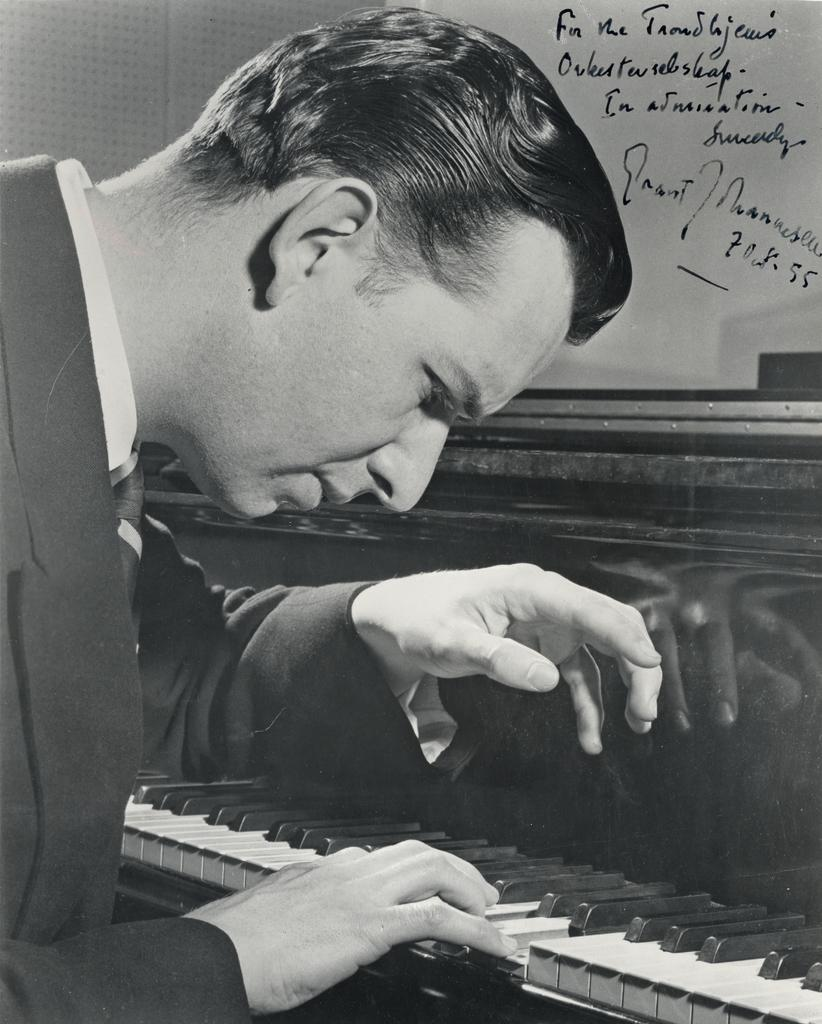What is the color scheme of the image? The image is black and white. What activity is the man in the image engaged in? The man is playing the piano in the image. What object is present in the image that can reflect images? There is a mirror in the image. What is written on the mirror in the image? Something is written on the mirror with a pen. Can you see any ants crawling on the piano in the image? There are no ants visible in the image; it only features a man playing the piano, a mirror, and writing on the mirror. 